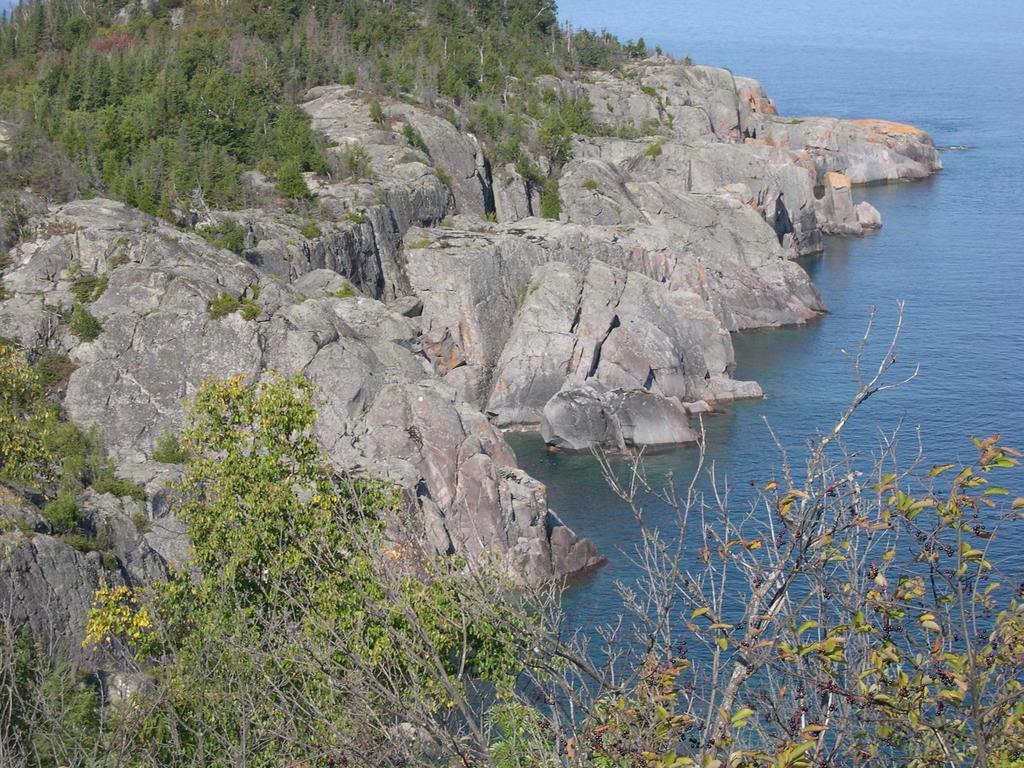What type of natural elements can be seen in the image? There are rocks and trees in the image. What body of water is present in the image? There is a sea in the image. Is there any water visible in the image? Yes, water is visible in the image. What type of sack can be seen hanging from the tree in the image? There is no sack present in the image; it only features rocks, trees, a sea, and water. 